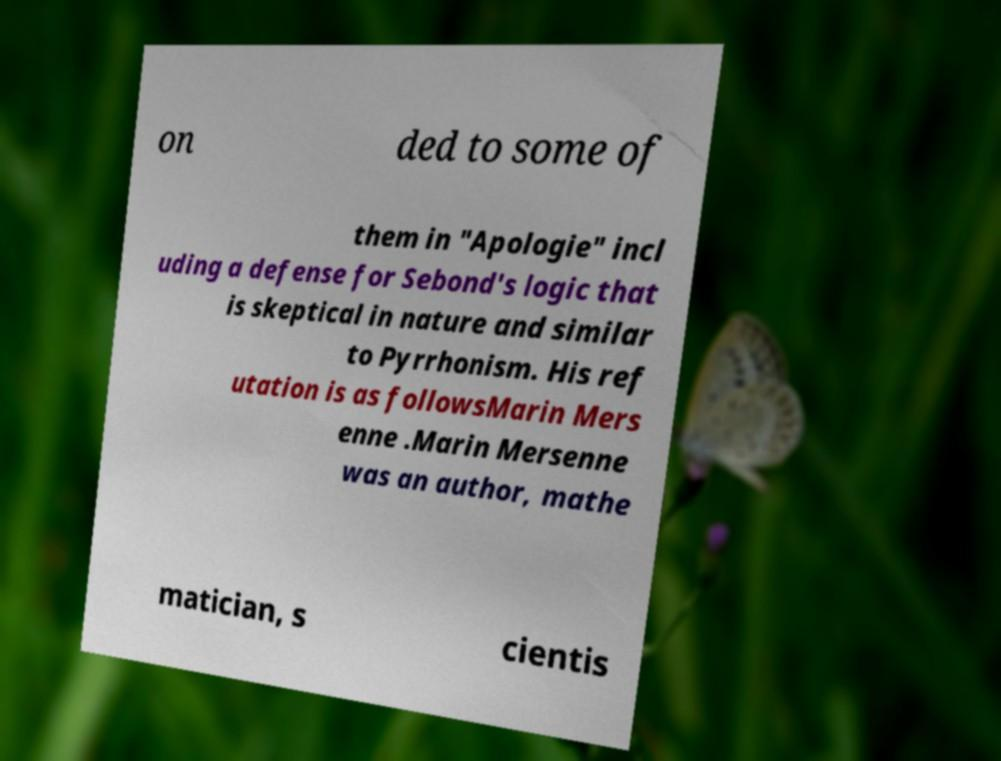Please identify and transcribe the text found in this image. on ded to some of them in "Apologie" incl uding a defense for Sebond's logic that is skeptical in nature and similar to Pyrrhonism. His ref utation is as followsMarin Mers enne .Marin Mersenne was an author, mathe matician, s cientis 